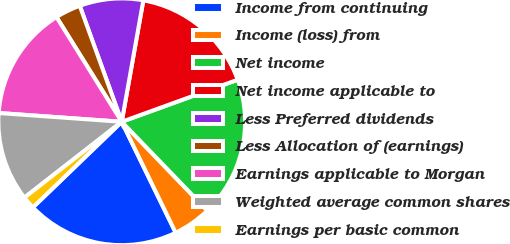Convert chart to OTSL. <chart><loc_0><loc_0><loc_500><loc_500><pie_chart><fcel>Income from continuing<fcel>Income (loss) from<fcel>Net income<fcel>Net income applicable to<fcel>Less Preferred dividends<fcel>Less Allocation of (earnings)<fcel>Earnings applicable to Morgan<fcel>Weighted average common shares<fcel>Earnings per basic common<nl><fcel>20.0%<fcel>5.0%<fcel>18.33%<fcel>16.66%<fcel>8.33%<fcel>3.34%<fcel>15.0%<fcel>11.67%<fcel>1.67%<nl></chart> 